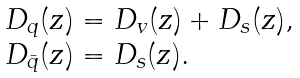Convert formula to latex. <formula><loc_0><loc_0><loc_500><loc_500>\begin{array} { l l } { { D _ { q } ( z ) = D _ { v } ( z ) + D _ { s } ( z ) , } } \\ { { D _ { \bar { q } } ( z ) = D _ { s } ( z ) . } } \end{array}</formula> 